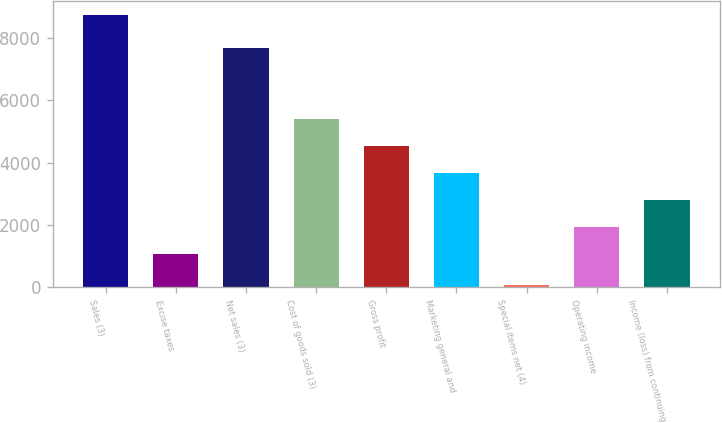Convert chart. <chart><loc_0><loc_0><loc_500><loc_500><bar_chart><fcel>Sales (3)<fcel>Excise taxes<fcel>Net sales (3)<fcel>Cost of goods sold (3)<fcel>Gross profit<fcel>Marketing general and<fcel>Special items net (4)<fcel>Operating income<fcel>Income (loss) from continuing<nl><fcel>8744<fcel>1062.9<fcel>7681.1<fcel>5389.15<fcel>4523.9<fcel>3658.65<fcel>91.5<fcel>1928.15<fcel>2793.4<nl></chart> 